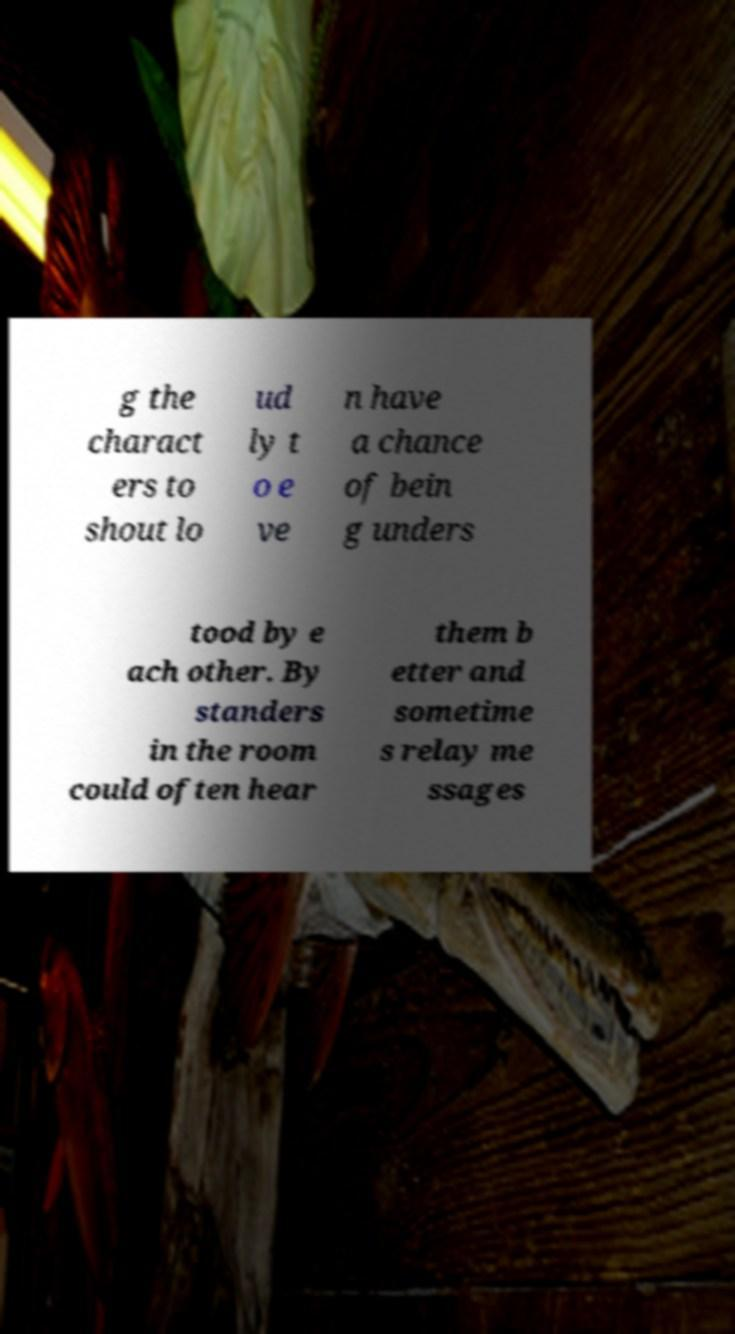Please identify and transcribe the text found in this image. g the charact ers to shout lo ud ly t o e ve n have a chance of bein g unders tood by e ach other. By standers in the room could often hear them b etter and sometime s relay me ssages 